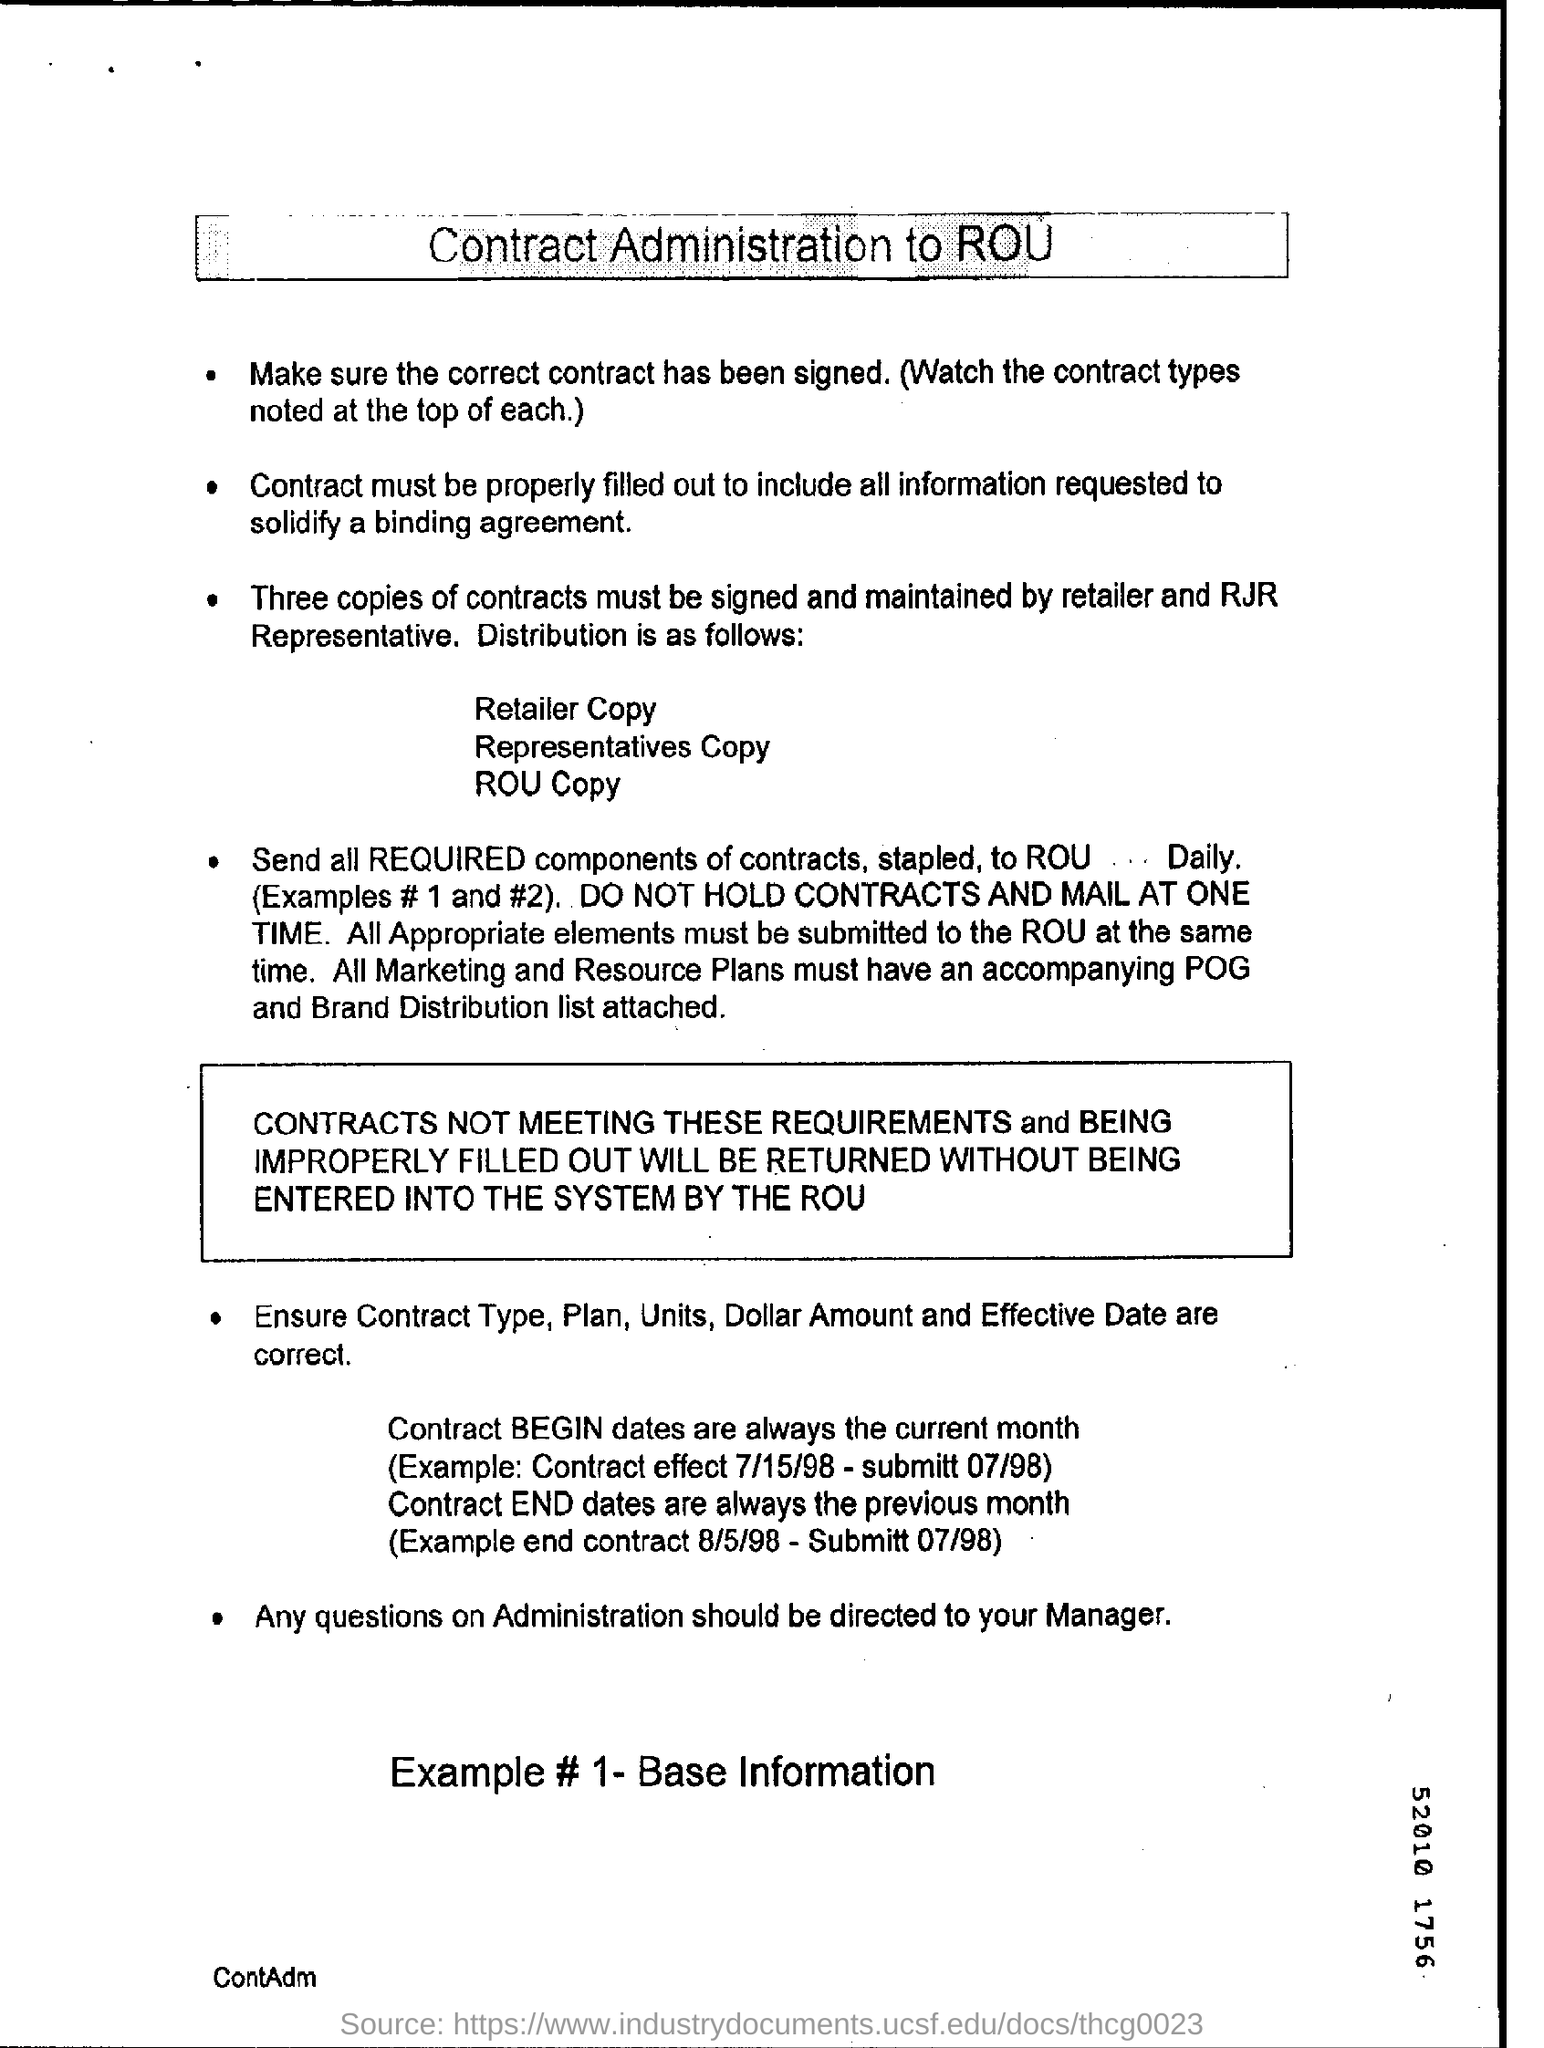How many copies of contracts must be signed and maintained by retailer and RJR Representative?
Your answer should be compact. Three copies. What is the current month in the contract?
Ensure brevity in your answer.  BEGIN dates. To whom should  be questions on Administration directed ?
Provide a succinct answer. Your Manager. 